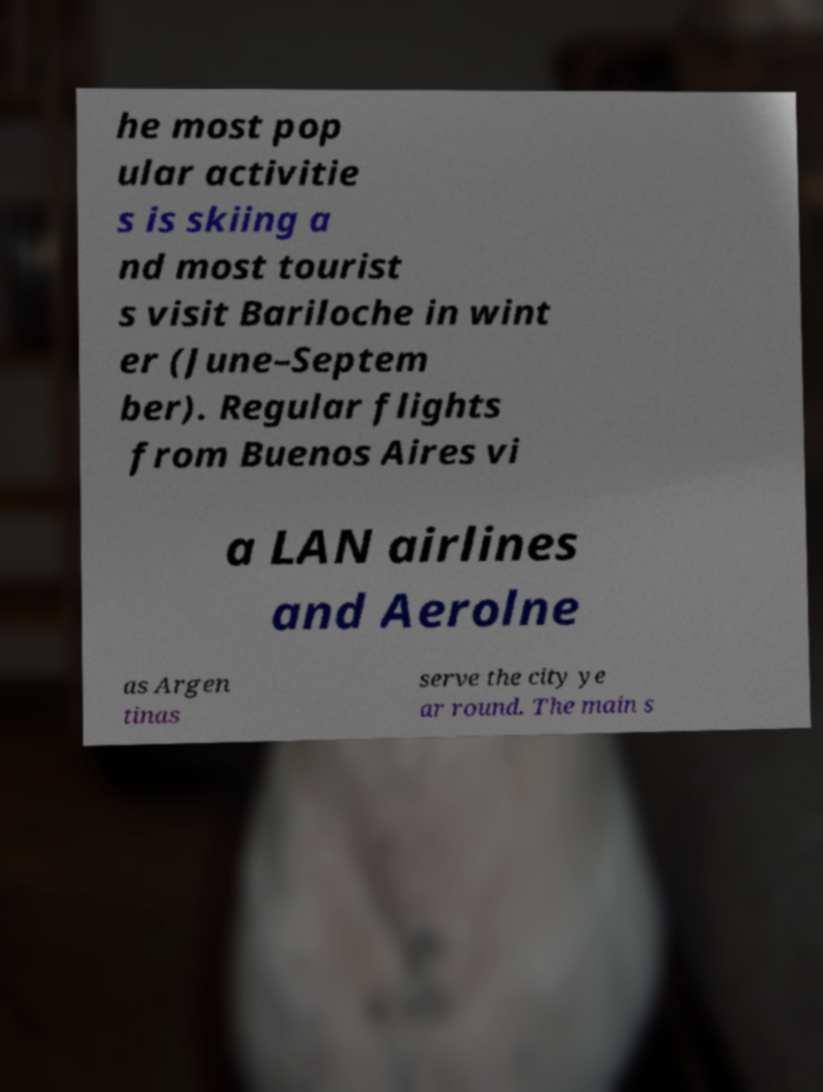For documentation purposes, I need the text within this image transcribed. Could you provide that? he most pop ular activitie s is skiing a nd most tourist s visit Bariloche in wint er (June–Septem ber). Regular flights from Buenos Aires vi a LAN airlines and Aerolne as Argen tinas serve the city ye ar round. The main s 